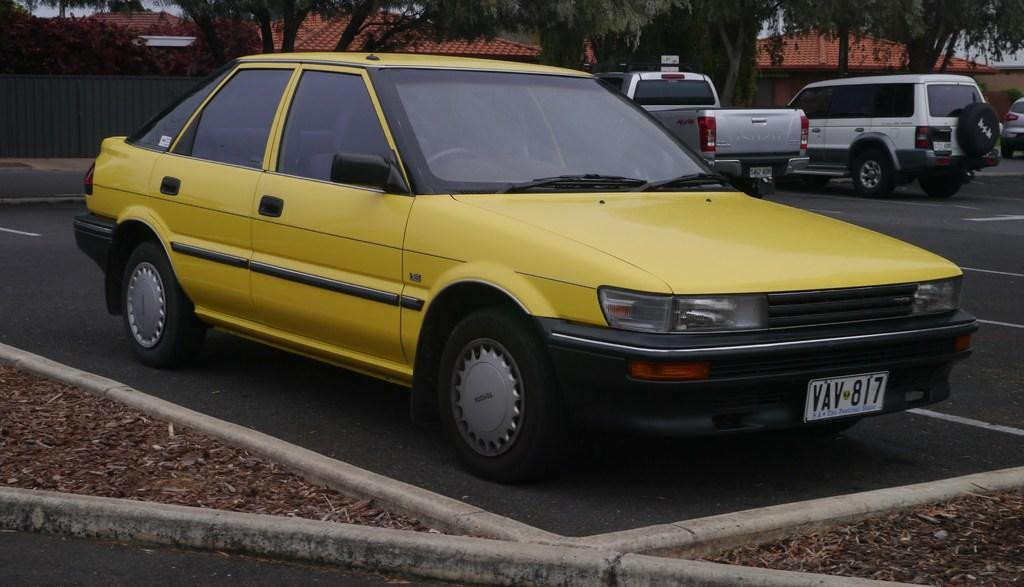What color is the car in the image? The car in the image is yellow. What is the car doing in the image? The car is parked. What can be seen on the ground near the car? Dry leaves are visible in the image. What can be seen in the background of the image? There are other cars parked on the road, a fence, trees, and houses visible in the background. What type of dress is the fan wearing in the image? There is no fan or dress present in the image. 